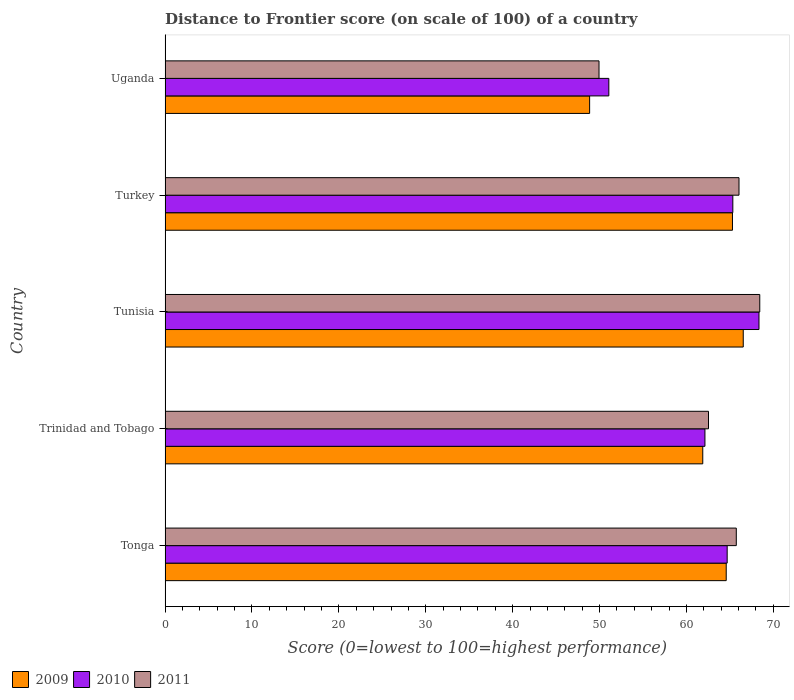How many different coloured bars are there?
Your answer should be compact. 3. How many groups of bars are there?
Your answer should be very brief. 5. Are the number of bars per tick equal to the number of legend labels?
Offer a very short reply. Yes. Are the number of bars on each tick of the Y-axis equal?
Offer a very short reply. Yes. What is the label of the 4th group of bars from the top?
Make the answer very short. Trinidad and Tobago. What is the distance to frontier score of in 2010 in Turkey?
Offer a terse response. 65.34. Across all countries, what is the maximum distance to frontier score of in 2009?
Your answer should be very brief. 66.54. Across all countries, what is the minimum distance to frontier score of in 2010?
Make the answer very short. 51.07. In which country was the distance to frontier score of in 2010 maximum?
Provide a short and direct response. Tunisia. In which country was the distance to frontier score of in 2010 minimum?
Offer a very short reply. Uganda. What is the total distance to frontier score of in 2009 in the graph?
Provide a short and direct response. 307.16. What is the difference between the distance to frontier score of in 2011 in Tunisia and that in Turkey?
Your answer should be very brief. 2.39. What is the difference between the distance to frontier score of in 2010 in Uganda and the distance to frontier score of in 2011 in Trinidad and Tobago?
Offer a terse response. -11.47. What is the average distance to frontier score of in 2009 per country?
Give a very brief answer. 61.43. What is the difference between the distance to frontier score of in 2010 and distance to frontier score of in 2009 in Turkey?
Give a very brief answer. 0.04. What is the ratio of the distance to frontier score of in 2009 in Tonga to that in Trinidad and Tobago?
Offer a terse response. 1.04. What is the difference between the highest and the second highest distance to frontier score of in 2011?
Your answer should be very brief. 2.39. In how many countries, is the distance to frontier score of in 2009 greater than the average distance to frontier score of in 2009 taken over all countries?
Your answer should be compact. 4. How many bars are there?
Make the answer very short. 15. How many countries are there in the graph?
Make the answer very short. 5. Are the values on the major ticks of X-axis written in scientific E-notation?
Give a very brief answer. No. Does the graph contain any zero values?
Your response must be concise. No. Where does the legend appear in the graph?
Make the answer very short. Bottom left. How many legend labels are there?
Keep it short and to the point. 3. What is the title of the graph?
Offer a very short reply. Distance to Frontier score (on scale of 100) of a country. What is the label or title of the X-axis?
Provide a succinct answer. Score (0=lowest to 100=highest performance). What is the Score (0=lowest to 100=highest performance) in 2009 in Tonga?
Your answer should be compact. 64.58. What is the Score (0=lowest to 100=highest performance) of 2010 in Tonga?
Give a very brief answer. 64.69. What is the Score (0=lowest to 100=highest performance) in 2011 in Tonga?
Your response must be concise. 65.74. What is the Score (0=lowest to 100=highest performance) of 2009 in Trinidad and Tobago?
Your answer should be compact. 61.88. What is the Score (0=lowest to 100=highest performance) of 2010 in Trinidad and Tobago?
Provide a succinct answer. 62.13. What is the Score (0=lowest to 100=highest performance) in 2011 in Trinidad and Tobago?
Offer a terse response. 62.54. What is the Score (0=lowest to 100=highest performance) of 2009 in Tunisia?
Offer a very short reply. 66.54. What is the Score (0=lowest to 100=highest performance) in 2010 in Tunisia?
Offer a terse response. 68.35. What is the Score (0=lowest to 100=highest performance) of 2011 in Tunisia?
Keep it short and to the point. 68.44. What is the Score (0=lowest to 100=highest performance) of 2009 in Turkey?
Provide a succinct answer. 65.3. What is the Score (0=lowest to 100=highest performance) of 2010 in Turkey?
Make the answer very short. 65.34. What is the Score (0=lowest to 100=highest performance) of 2011 in Turkey?
Your answer should be very brief. 66.05. What is the Score (0=lowest to 100=highest performance) of 2009 in Uganda?
Your response must be concise. 48.86. What is the Score (0=lowest to 100=highest performance) of 2010 in Uganda?
Make the answer very short. 51.07. What is the Score (0=lowest to 100=highest performance) in 2011 in Uganda?
Keep it short and to the point. 49.94. Across all countries, what is the maximum Score (0=lowest to 100=highest performance) of 2009?
Provide a succinct answer. 66.54. Across all countries, what is the maximum Score (0=lowest to 100=highest performance) in 2010?
Provide a succinct answer. 68.35. Across all countries, what is the maximum Score (0=lowest to 100=highest performance) of 2011?
Your answer should be very brief. 68.44. Across all countries, what is the minimum Score (0=lowest to 100=highest performance) of 2009?
Provide a succinct answer. 48.86. Across all countries, what is the minimum Score (0=lowest to 100=highest performance) in 2010?
Make the answer very short. 51.07. Across all countries, what is the minimum Score (0=lowest to 100=highest performance) of 2011?
Your answer should be compact. 49.94. What is the total Score (0=lowest to 100=highest performance) of 2009 in the graph?
Keep it short and to the point. 307.16. What is the total Score (0=lowest to 100=highest performance) in 2010 in the graph?
Ensure brevity in your answer.  311.58. What is the total Score (0=lowest to 100=highest performance) of 2011 in the graph?
Your answer should be compact. 312.71. What is the difference between the Score (0=lowest to 100=highest performance) in 2009 in Tonga and that in Trinidad and Tobago?
Your response must be concise. 2.7. What is the difference between the Score (0=lowest to 100=highest performance) of 2010 in Tonga and that in Trinidad and Tobago?
Keep it short and to the point. 2.56. What is the difference between the Score (0=lowest to 100=highest performance) of 2011 in Tonga and that in Trinidad and Tobago?
Provide a short and direct response. 3.2. What is the difference between the Score (0=lowest to 100=highest performance) in 2009 in Tonga and that in Tunisia?
Keep it short and to the point. -1.96. What is the difference between the Score (0=lowest to 100=highest performance) of 2010 in Tonga and that in Tunisia?
Keep it short and to the point. -3.66. What is the difference between the Score (0=lowest to 100=highest performance) in 2009 in Tonga and that in Turkey?
Provide a short and direct response. -0.72. What is the difference between the Score (0=lowest to 100=highest performance) in 2010 in Tonga and that in Turkey?
Provide a succinct answer. -0.65. What is the difference between the Score (0=lowest to 100=highest performance) of 2011 in Tonga and that in Turkey?
Provide a succinct answer. -0.31. What is the difference between the Score (0=lowest to 100=highest performance) of 2009 in Tonga and that in Uganda?
Provide a succinct answer. 15.72. What is the difference between the Score (0=lowest to 100=highest performance) of 2010 in Tonga and that in Uganda?
Offer a very short reply. 13.62. What is the difference between the Score (0=lowest to 100=highest performance) of 2011 in Tonga and that in Uganda?
Your answer should be compact. 15.8. What is the difference between the Score (0=lowest to 100=highest performance) in 2009 in Trinidad and Tobago and that in Tunisia?
Keep it short and to the point. -4.66. What is the difference between the Score (0=lowest to 100=highest performance) in 2010 in Trinidad and Tobago and that in Tunisia?
Keep it short and to the point. -6.22. What is the difference between the Score (0=lowest to 100=highest performance) in 2009 in Trinidad and Tobago and that in Turkey?
Your answer should be very brief. -3.42. What is the difference between the Score (0=lowest to 100=highest performance) of 2010 in Trinidad and Tobago and that in Turkey?
Give a very brief answer. -3.21. What is the difference between the Score (0=lowest to 100=highest performance) in 2011 in Trinidad and Tobago and that in Turkey?
Make the answer very short. -3.51. What is the difference between the Score (0=lowest to 100=highest performance) of 2009 in Trinidad and Tobago and that in Uganda?
Ensure brevity in your answer.  13.02. What is the difference between the Score (0=lowest to 100=highest performance) in 2010 in Trinidad and Tobago and that in Uganda?
Give a very brief answer. 11.06. What is the difference between the Score (0=lowest to 100=highest performance) of 2009 in Tunisia and that in Turkey?
Keep it short and to the point. 1.24. What is the difference between the Score (0=lowest to 100=highest performance) in 2010 in Tunisia and that in Turkey?
Provide a succinct answer. 3.01. What is the difference between the Score (0=lowest to 100=highest performance) of 2011 in Tunisia and that in Turkey?
Ensure brevity in your answer.  2.39. What is the difference between the Score (0=lowest to 100=highest performance) of 2009 in Tunisia and that in Uganda?
Make the answer very short. 17.68. What is the difference between the Score (0=lowest to 100=highest performance) in 2010 in Tunisia and that in Uganda?
Ensure brevity in your answer.  17.28. What is the difference between the Score (0=lowest to 100=highest performance) of 2009 in Turkey and that in Uganda?
Ensure brevity in your answer.  16.44. What is the difference between the Score (0=lowest to 100=highest performance) in 2010 in Turkey and that in Uganda?
Your answer should be very brief. 14.27. What is the difference between the Score (0=lowest to 100=highest performance) of 2011 in Turkey and that in Uganda?
Provide a short and direct response. 16.11. What is the difference between the Score (0=lowest to 100=highest performance) of 2009 in Tonga and the Score (0=lowest to 100=highest performance) of 2010 in Trinidad and Tobago?
Offer a very short reply. 2.45. What is the difference between the Score (0=lowest to 100=highest performance) of 2009 in Tonga and the Score (0=lowest to 100=highest performance) of 2011 in Trinidad and Tobago?
Ensure brevity in your answer.  2.04. What is the difference between the Score (0=lowest to 100=highest performance) in 2010 in Tonga and the Score (0=lowest to 100=highest performance) in 2011 in Trinidad and Tobago?
Make the answer very short. 2.15. What is the difference between the Score (0=lowest to 100=highest performance) of 2009 in Tonga and the Score (0=lowest to 100=highest performance) of 2010 in Tunisia?
Your answer should be compact. -3.77. What is the difference between the Score (0=lowest to 100=highest performance) of 2009 in Tonga and the Score (0=lowest to 100=highest performance) of 2011 in Tunisia?
Your answer should be very brief. -3.86. What is the difference between the Score (0=lowest to 100=highest performance) of 2010 in Tonga and the Score (0=lowest to 100=highest performance) of 2011 in Tunisia?
Offer a terse response. -3.75. What is the difference between the Score (0=lowest to 100=highest performance) of 2009 in Tonga and the Score (0=lowest to 100=highest performance) of 2010 in Turkey?
Offer a very short reply. -0.76. What is the difference between the Score (0=lowest to 100=highest performance) of 2009 in Tonga and the Score (0=lowest to 100=highest performance) of 2011 in Turkey?
Make the answer very short. -1.47. What is the difference between the Score (0=lowest to 100=highest performance) of 2010 in Tonga and the Score (0=lowest to 100=highest performance) of 2011 in Turkey?
Offer a terse response. -1.36. What is the difference between the Score (0=lowest to 100=highest performance) of 2009 in Tonga and the Score (0=lowest to 100=highest performance) of 2010 in Uganda?
Ensure brevity in your answer.  13.51. What is the difference between the Score (0=lowest to 100=highest performance) in 2009 in Tonga and the Score (0=lowest to 100=highest performance) in 2011 in Uganda?
Provide a short and direct response. 14.64. What is the difference between the Score (0=lowest to 100=highest performance) of 2010 in Tonga and the Score (0=lowest to 100=highest performance) of 2011 in Uganda?
Your answer should be very brief. 14.75. What is the difference between the Score (0=lowest to 100=highest performance) in 2009 in Trinidad and Tobago and the Score (0=lowest to 100=highest performance) in 2010 in Tunisia?
Offer a very short reply. -6.47. What is the difference between the Score (0=lowest to 100=highest performance) in 2009 in Trinidad and Tobago and the Score (0=lowest to 100=highest performance) in 2011 in Tunisia?
Provide a short and direct response. -6.56. What is the difference between the Score (0=lowest to 100=highest performance) of 2010 in Trinidad and Tobago and the Score (0=lowest to 100=highest performance) of 2011 in Tunisia?
Provide a short and direct response. -6.31. What is the difference between the Score (0=lowest to 100=highest performance) in 2009 in Trinidad and Tobago and the Score (0=lowest to 100=highest performance) in 2010 in Turkey?
Provide a succinct answer. -3.46. What is the difference between the Score (0=lowest to 100=highest performance) of 2009 in Trinidad and Tobago and the Score (0=lowest to 100=highest performance) of 2011 in Turkey?
Your answer should be compact. -4.17. What is the difference between the Score (0=lowest to 100=highest performance) of 2010 in Trinidad and Tobago and the Score (0=lowest to 100=highest performance) of 2011 in Turkey?
Your answer should be very brief. -3.92. What is the difference between the Score (0=lowest to 100=highest performance) in 2009 in Trinidad and Tobago and the Score (0=lowest to 100=highest performance) in 2010 in Uganda?
Provide a short and direct response. 10.81. What is the difference between the Score (0=lowest to 100=highest performance) of 2009 in Trinidad and Tobago and the Score (0=lowest to 100=highest performance) of 2011 in Uganda?
Your answer should be compact. 11.94. What is the difference between the Score (0=lowest to 100=highest performance) in 2010 in Trinidad and Tobago and the Score (0=lowest to 100=highest performance) in 2011 in Uganda?
Your response must be concise. 12.19. What is the difference between the Score (0=lowest to 100=highest performance) of 2009 in Tunisia and the Score (0=lowest to 100=highest performance) of 2010 in Turkey?
Ensure brevity in your answer.  1.2. What is the difference between the Score (0=lowest to 100=highest performance) in 2009 in Tunisia and the Score (0=lowest to 100=highest performance) in 2011 in Turkey?
Offer a very short reply. 0.49. What is the difference between the Score (0=lowest to 100=highest performance) of 2010 in Tunisia and the Score (0=lowest to 100=highest performance) of 2011 in Turkey?
Offer a very short reply. 2.3. What is the difference between the Score (0=lowest to 100=highest performance) in 2009 in Tunisia and the Score (0=lowest to 100=highest performance) in 2010 in Uganda?
Offer a terse response. 15.47. What is the difference between the Score (0=lowest to 100=highest performance) in 2010 in Tunisia and the Score (0=lowest to 100=highest performance) in 2011 in Uganda?
Your answer should be compact. 18.41. What is the difference between the Score (0=lowest to 100=highest performance) of 2009 in Turkey and the Score (0=lowest to 100=highest performance) of 2010 in Uganda?
Provide a succinct answer. 14.23. What is the difference between the Score (0=lowest to 100=highest performance) in 2009 in Turkey and the Score (0=lowest to 100=highest performance) in 2011 in Uganda?
Your response must be concise. 15.36. What is the average Score (0=lowest to 100=highest performance) of 2009 per country?
Provide a short and direct response. 61.43. What is the average Score (0=lowest to 100=highest performance) of 2010 per country?
Keep it short and to the point. 62.32. What is the average Score (0=lowest to 100=highest performance) of 2011 per country?
Give a very brief answer. 62.54. What is the difference between the Score (0=lowest to 100=highest performance) of 2009 and Score (0=lowest to 100=highest performance) of 2010 in Tonga?
Provide a succinct answer. -0.11. What is the difference between the Score (0=lowest to 100=highest performance) in 2009 and Score (0=lowest to 100=highest performance) in 2011 in Tonga?
Provide a succinct answer. -1.16. What is the difference between the Score (0=lowest to 100=highest performance) of 2010 and Score (0=lowest to 100=highest performance) of 2011 in Tonga?
Your answer should be very brief. -1.05. What is the difference between the Score (0=lowest to 100=highest performance) in 2009 and Score (0=lowest to 100=highest performance) in 2011 in Trinidad and Tobago?
Your answer should be compact. -0.66. What is the difference between the Score (0=lowest to 100=highest performance) of 2010 and Score (0=lowest to 100=highest performance) of 2011 in Trinidad and Tobago?
Your answer should be very brief. -0.41. What is the difference between the Score (0=lowest to 100=highest performance) of 2009 and Score (0=lowest to 100=highest performance) of 2010 in Tunisia?
Your response must be concise. -1.81. What is the difference between the Score (0=lowest to 100=highest performance) in 2010 and Score (0=lowest to 100=highest performance) in 2011 in Tunisia?
Offer a very short reply. -0.09. What is the difference between the Score (0=lowest to 100=highest performance) in 2009 and Score (0=lowest to 100=highest performance) in 2010 in Turkey?
Your response must be concise. -0.04. What is the difference between the Score (0=lowest to 100=highest performance) in 2009 and Score (0=lowest to 100=highest performance) in 2011 in Turkey?
Offer a terse response. -0.75. What is the difference between the Score (0=lowest to 100=highest performance) in 2010 and Score (0=lowest to 100=highest performance) in 2011 in Turkey?
Provide a succinct answer. -0.71. What is the difference between the Score (0=lowest to 100=highest performance) of 2009 and Score (0=lowest to 100=highest performance) of 2010 in Uganda?
Make the answer very short. -2.21. What is the difference between the Score (0=lowest to 100=highest performance) of 2009 and Score (0=lowest to 100=highest performance) of 2011 in Uganda?
Give a very brief answer. -1.08. What is the difference between the Score (0=lowest to 100=highest performance) in 2010 and Score (0=lowest to 100=highest performance) in 2011 in Uganda?
Keep it short and to the point. 1.13. What is the ratio of the Score (0=lowest to 100=highest performance) in 2009 in Tonga to that in Trinidad and Tobago?
Your answer should be very brief. 1.04. What is the ratio of the Score (0=lowest to 100=highest performance) of 2010 in Tonga to that in Trinidad and Tobago?
Make the answer very short. 1.04. What is the ratio of the Score (0=lowest to 100=highest performance) in 2011 in Tonga to that in Trinidad and Tobago?
Offer a very short reply. 1.05. What is the ratio of the Score (0=lowest to 100=highest performance) in 2009 in Tonga to that in Tunisia?
Ensure brevity in your answer.  0.97. What is the ratio of the Score (0=lowest to 100=highest performance) in 2010 in Tonga to that in Tunisia?
Provide a succinct answer. 0.95. What is the ratio of the Score (0=lowest to 100=highest performance) in 2011 in Tonga to that in Tunisia?
Ensure brevity in your answer.  0.96. What is the ratio of the Score (0=lowest to 100=highest performance) of 2009 in Tonga to that in Uganda?
Your answer should be very brief. 1.32. What is the ratio of the Score (0=lowest to 100=highest performance) of 2010 in Tonga to that in Uganda?
Offer a very short reply. 1.27. What is the ratio of the Score (0=lowest to 100=highest performance) in 2011 in Tonga to that in Uganda?
Give a very brief answer. 1.32. What is the ratio of the Score (0=lowest to 100=highest performance) of 2010 in Trinidad and Tobago to that in Tunisia?
Ensure brevity in your answer.  0.91. What is the ratio of the Score (0=lowest to 100=highest performance) in 2011 in Trinidad and Tobago to that in Tunisia?
Provide a succinct answer. 0.91. What is the ratio of the Score (0=lowest to 100=highest performance) in 2009 in Trinidad and Tobago to that in Turkey?
Ensure brevity in your answer.  0.95. What is the ratio of the Score (0=lowest to 100=highest performance) in 2010 in Trinidad and Tobago to that in Turkey?
Make the answer very short. 0.95. What is the ratio of the Score (0=lowest to 100=highest performance) of 2011 in Trinidad and Tobago to that in Turkey?
Ensure brevity in your answer.  0.95. What is the ratio of the Score (0=lowest to 100=highest performance) of 2009 in Trinidad and Tobago to that in Uganda?
Make the answer very short. 1.27. What is the ratio of the Score (0=lowest to 100=highest performance) in 2010 in Trinidad and Tobago to that in Uganda?
Ensure brevity in your answer.  1.22. What is the ratio of the Score (0=lowest to 100=highest performance) in 2011 in Trinidad and Tobago to that in Uganda?
Your answer should be very brief. 1.25. What is the ratio of the Score (0=lowest to 100=highest performance) in 2009 in Tunisia to that in Turkey?
Make the answer very short. 1.02. What is the ratio of the Score (0=lowest to 100=highest performance) in 2010 in Tunisia to that in Turkey?
Give a very brief answer. 1.05. What is the ratio of the Score (0=lowest to 100=highest performance) of 2011 in Tunisia to that in Turkey?
Give a very brief answer. 1.04. What is the ratio of the Score (0=lowest to 100=highest performance) of 2009 in Tunisia to that in Uganda?
Offer a terse response. 1.36. What is the ratio of the Score (0=lowest to 100=highest performance) in 2010 in Tunisia to that in Uganda?
Your response must be concise. 1.34. What is the ratio of the Score (0=lowest to 100=highest performance) in 2011 in Tunisia to that in Uganda?
Give a very brief answer. 1.37. What is the ratio of the Score (0=lowest to 100=highest performance) in 2009 in Turkey to that in Uganda?
Give a very brief answer. 1.34. What is the ratio of the Score (0=lowest to 100=highest performance) in 2010 in Turkey to that in Uganda?
Your response must be concise. 1.28. What is the ratio of the Score (0=lowest to 100=highest performance) in 2011 in Turkey to that in Uganda?
Provide a succinct answer. 1.32. What is the difference between the highest and the second highest Score (0=lowest to 100=highest performance) of 2009?
Your answer should be very brief. 1.24. What is the difference between the highest and the second highest Score (0=lowest to 100=highest performance) of 2010?
Your answer should be very brief. 3.01. What is the difference between the highest and the second highest Score (0=lowest to 100=highest performance) of 2011?
Make the answer very short. 2.39. What is the difference between the highest and the lowest Score (0=lowest to 100=highest performance) of 2009?
Give a very brief answer. 17.68. What is the difference between the highest and the lowest Score (0=lowest to 100=highest performance) in 2010?
Make the answer very short. 17.28. What is the difference between the highest and the lowest Score (0=lowest to 100=highest performance) of 2011?
Provide a short and direct response. 18.5. 